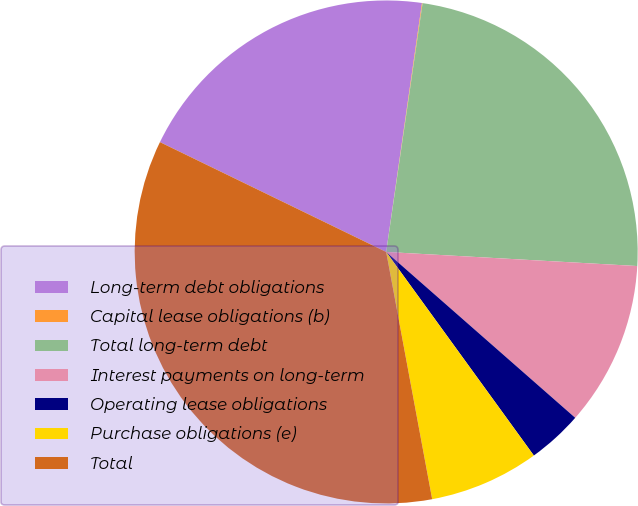Convert chart. <chart><loc_0><loc_0><loc_500><loc_500><pie_chart><fcel>Long-term debt obligations<fcel>Capital lease obligations (b)<fcel>Total long-term debt<fcel>Interest payments on long-term<fcel>Operating lease obligations<fcel>Purchase obligations (e)<fcel>Total<nl><fcel>20.08%<fcel>0.04%<fcel>23.58%<fcel>10.57%<fcel>3.55%<fcel>7.06%<fcel>35.12%<nl></chart> 